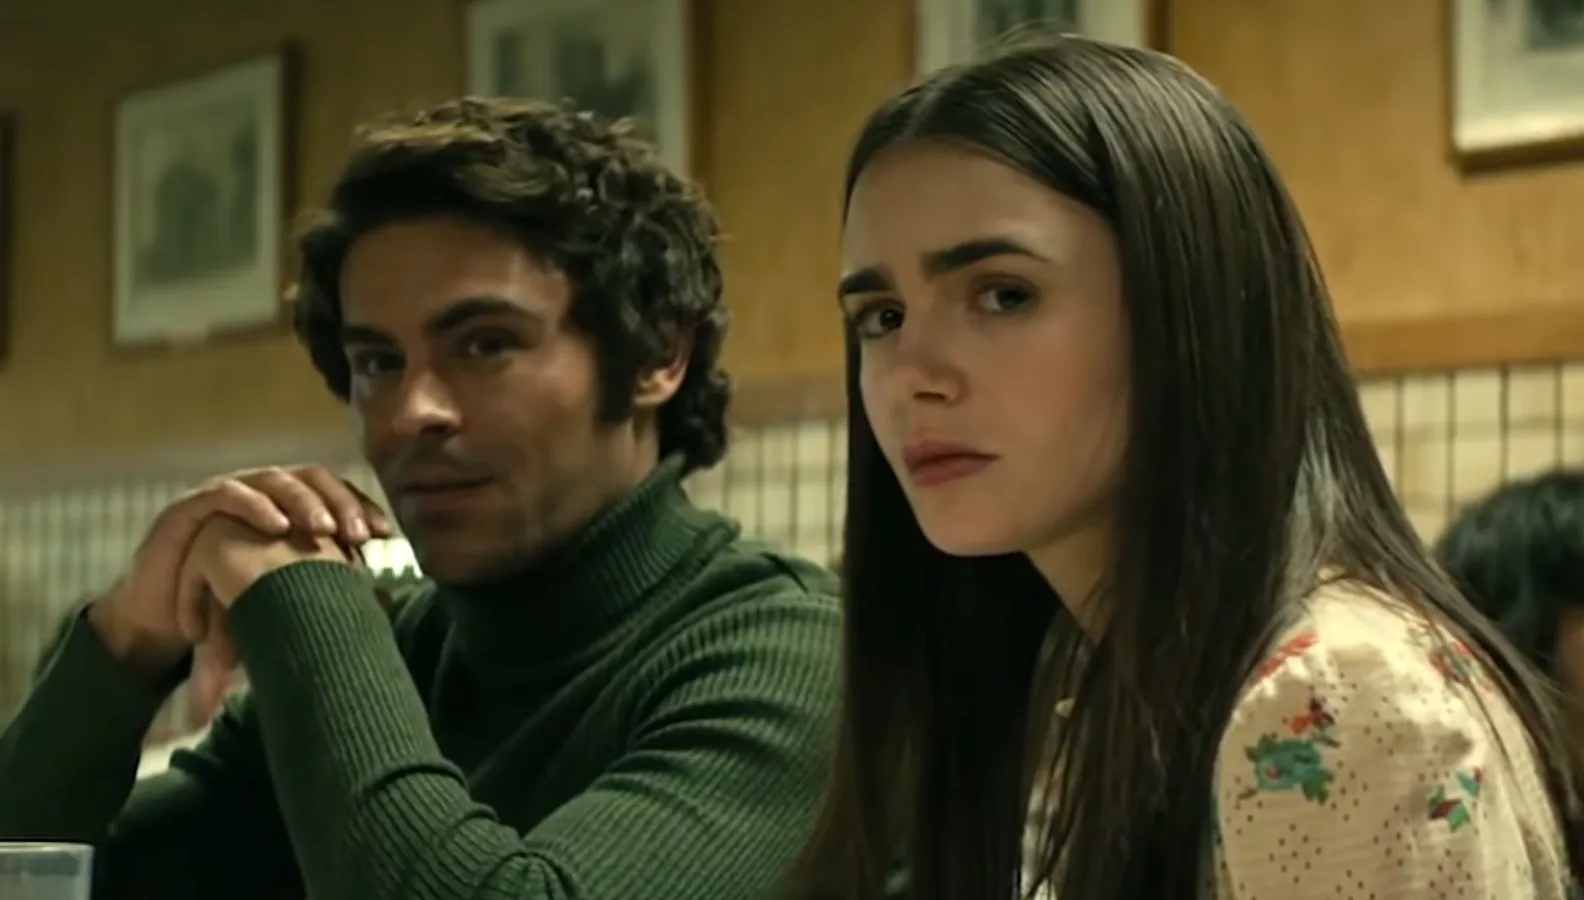What do the actors' expressions and body language tell us about the scene's tone? The actors' expressions and body language convey a serious and contemplative tone. Zac Efron, with his chin resting on his hand, appears to be in deep thought or pondering something significant. Lily Collins' furrowed brow and direct gaze suggest concern or apprehension. Both characters seem to be processing or discussing something weighty, setting a somber and intense atmosphere in the scene. What might the characters be thinking or feeling in this moment? The characters might be experiencing a mix of introspection and unease. Zac Efron's posture indicates he is lost in thought, possibly weighing the consequences of a recent decision or reflecting on past events. Lily Collins' worried expression suggests she is deeply affected by whatever issue they are discussing. Together, their body language creates an impression of a pivotal and emotionally charged moment in the story. 